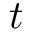Convert formula to latex. <formula><loc_0><loc_0><loc_500><loc_500>t</formula> 